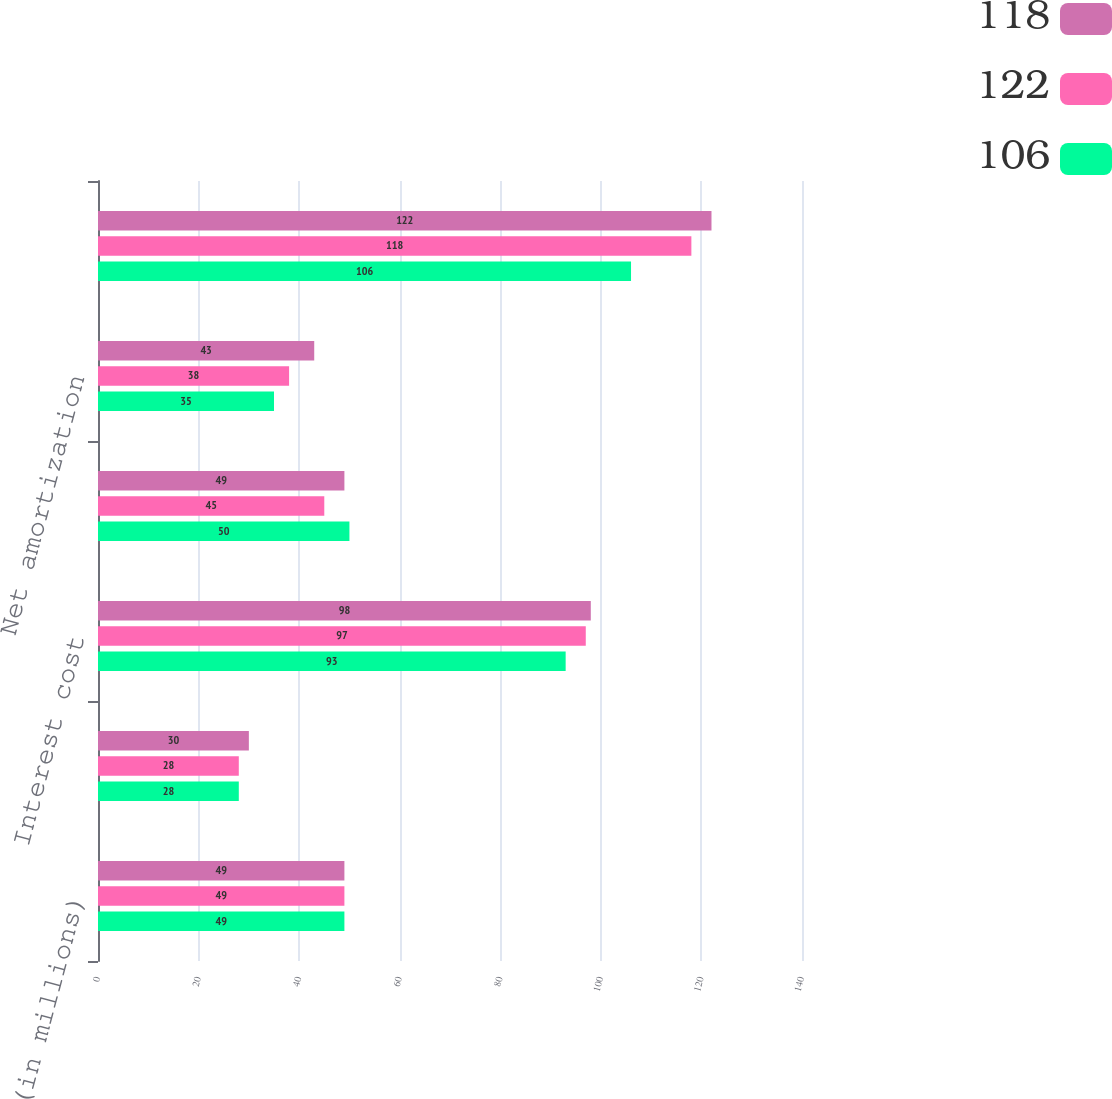Convert chart. <chart><loc_0><loc_0><loc_500><loc_500><stacked_bar_chart><ecel><fcel>(in millions)<fcel>Service cost<fcel>Interest cost<fcel>Expected return on plan assets<fcel>Net amortization<fcel>Net postretirement cost<nl><fcel>118<fcel>49<fcel>30<fcel>98<fcel>49<fcel>43<fcel>122<nl><fcel>122<fcel>49<fcel>28<fcel>97<fcel>45<fcel>38<fcel>118<nl><fcel>106<fcel>49<fcel>28<fcel>93<fcel>50<fcel>35<fcel>106<nl></chart> 